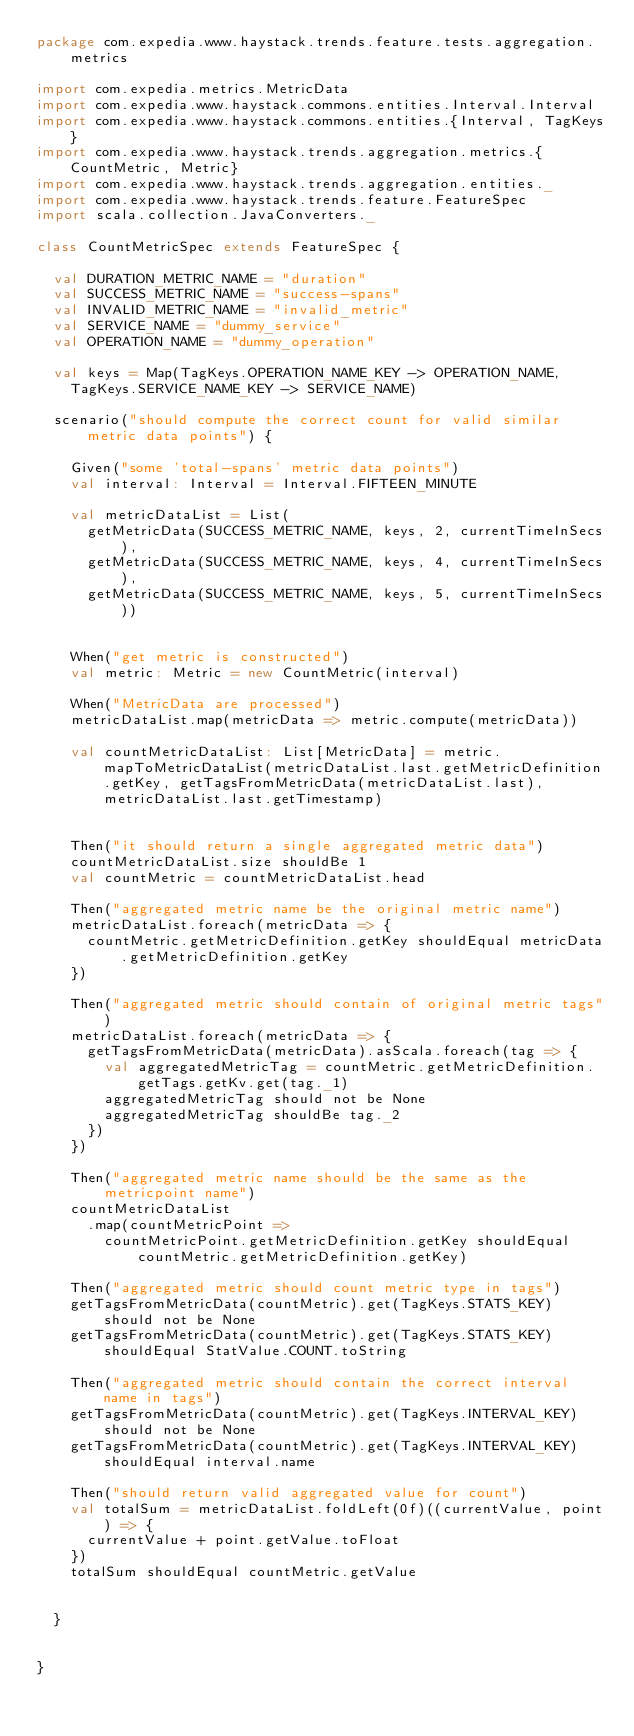<code> <loc_0><loc_0><loc_500><loc_500><_Scala_>package com.expedia.www.haystack.trends.feature.tests.aggregation.metrics

import com.expedia.metrics.MetricData
import com.expedia.www.haystack.commons.entities.Interval.Interval
import com.expedia.www.haystack.commons.entities.{Interval, TagKeys}
import com.expedia.www.haystack.trends.aggregation.metrics.{CountMetric, Metric}
import com.expedia.www.haystack.trends.aggregation.entities._
import com.expedia.www.haystack.trends.feature.FeatureSpec
import scala.collection.JavaConverters._

class CountMetricSpec extends FeatureSpec {

  val DURATION_METRIC_NAME = "duration"
  val SUCCESS_METRIC_NAME = "success-spans"
  val INVALID_METRIC_NAME = "invalid_metric"
  val SERVICE_NAME = "dummy_service"
  val OPERATION_NAME = "dummy_operation"

  val keys = Map(TagKeys.OPERATION_NAME_KEY -> OPERATION_NAME,
    TagKeys.SERVICE_NAME_KEY -> SERVICE_NAME)

  scenario("should compute the correct count for valid similar metric data points") {

    Given("some 'total-spans' metric data points")
    val interval: Interval = Interval.FIFTEEN_MINUTE

    val metricDataList = List(
      getMetricData(SUCCESS_METRIC_NAME, keys, 2, currentTimeInSecs),
      getMetricData(SUCCESS_METRIC_NAME, keys, 4, currentTimeInSecs),
      getMetricData(SUCCESS_METRIC_NAME, keys, 5, currentTimeInSecs))


    When("get metric is constructed")
    val metric: Metric = new CountMetric(interval)

    When("MetricData are processed")
    metricDataList.map(metricData => metric.compute(metricData))

    val countMetricDataList: List[MetricData] = metric.mapToMetricDataList(metricDataList.last.getMetricDefinition.getKey, getTagsFromMetricData(metricDataList.last), metricDataList.last.getTimestamp)


    Then("it should return a single aggregated metric data")
    countMetricDataList.size shouldBe 1
    val countMetric = countMetricDataList.head

    Then("aggregated metric name be the original metric name")
    metricDataList.foreach(metricData => {
      countMetric.getMetricDefinition.getKey shouldEqual metricData.getMetricDefinition.getKey
    })

    Then("aggregated metric should contain of original metric tags")
    metricDataList.foreach(metricData => {
      getTagsFromMetricData(metricData).asScala.foreach(tag => {
        val aggregatedMetricTag = countMetric.getMetricDefinition.getTags.getKv.get(tag._1)
        aggregatedMetricTag should not be None
        aggregatedMetricTag shouldBe tag._2
      })
    })

    Then("aggregated metric name should be the same as the metricpoint name")
    countMetricDataList
      .map(countMetricPoint =>
        countMetricPoint.getMetricDefinition.getKey shouldEqual countMetric.getMetricDefinition.getKey)

    Then("aggregated metric should count metric type in tags")
    getTagsFromMetricData(countMetric).get(TagKeys.STATS_KEY) should not be None
    getTagsFromMetricData(countMetric).get(TagKeys.STATS_KEY) shouldEqual StatValue.COUNT.toString

    Then("aggregated metric should contain the correct interval name in tags")
    getTagsFromMetricData(countMetric).get(TagKeys.INTERVAL_KEY) should not be None
    getTagsFromMetricData(countMetric).get(TagKeys.INTERVAL_KEY) shouldEqual interval.name

    Then("should return valid aggregated value for count")
    val totalSum = metricDataList.foldLeft(0f)((currentValue, point) => {
      currentValue + point.getValue.toFloat
    })
    totalSum shouldEqual countMetric.getValue


  }


}
</code> 